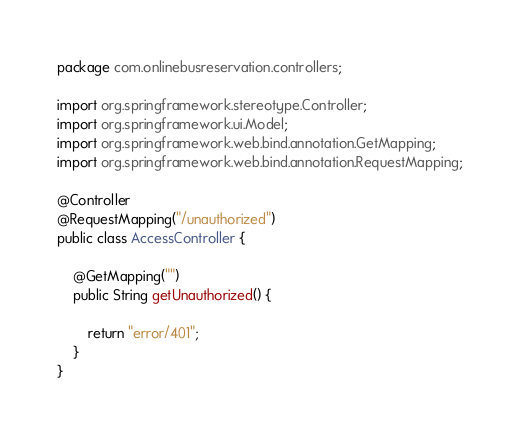Convert code to text. <code><loc_0><loc_0><loc_500><loc_500><_Java_>package com.onlinebusreservation.controllers;

import org.springframework.stereotype.Controller;
import org.springframework.ui.Model;
import org.springframework.web.bind.annotation.GetMapping;
import org.springframework.web.bind.annotation.RequestMapping;

@Controller
@RequestMapping("/unauthorized")
public class AccessController {

    @GetMapping("")
    public String getUnauthorized() {

        return "error/401";
    }
}
</code> 